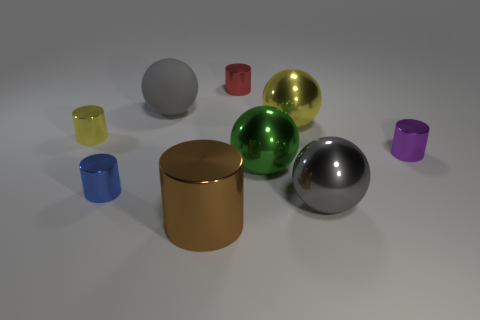How many objects can we see that have distinct colors? There are seven objects with distinct colors in the image, each one featuring a unique color such as red, yellow, green, blue, and purple. 